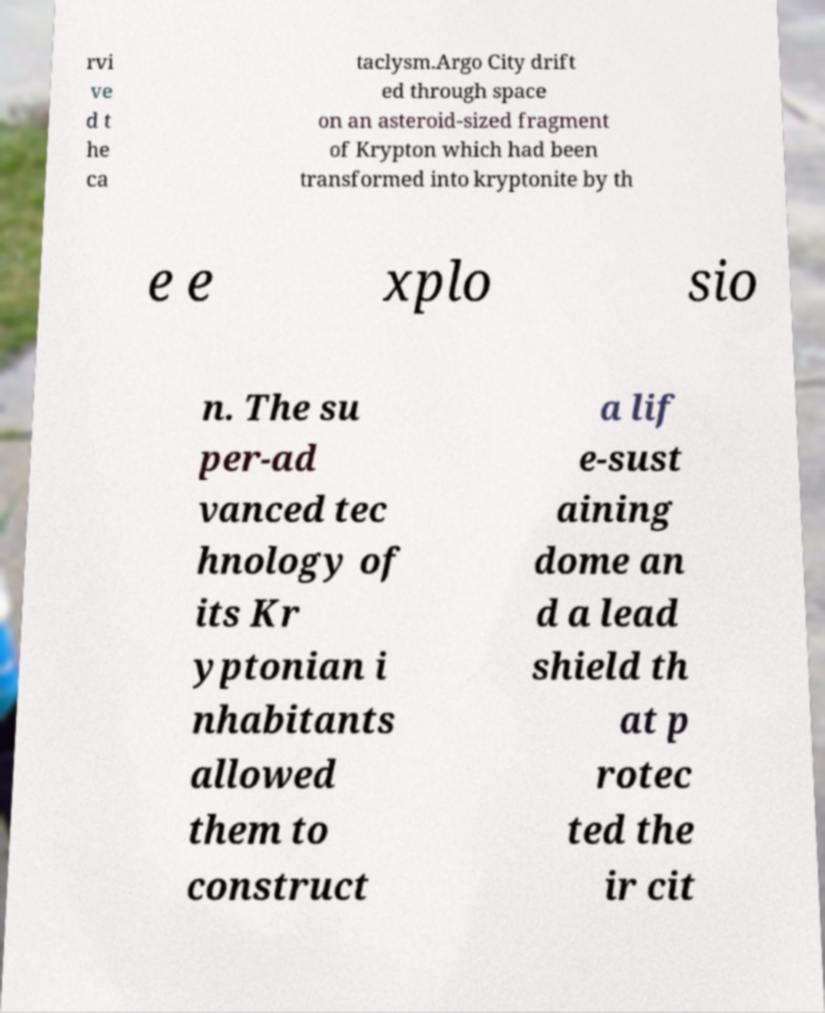I need the written content from this picture converted into text. Can you do that? rvi ve d t he ca taclysm.Argo City drift ed through space on an asteroid-sized fragment of Krypton which had been transformed into kryptonite by th e e xplo sio n. The su per-ad vanced tec hnology of its Kr yptonian i nhabitants allowed them to construct a lif e-sust aining dome an d a lead shield th at p rotec ted the ir cit 